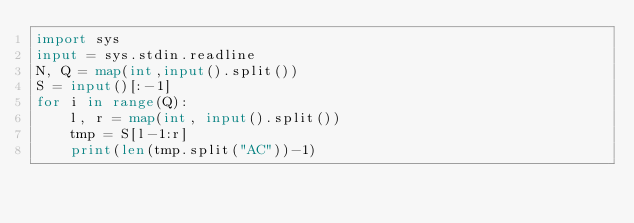Convert code to text. <code><loc_0><loc_0><loc_500><loc_500><_Python_>import sys
input = sys.stdin.readline
N, Q = map(int,input().split())
S = input()[:-1]
for i in range(Q):
    l, r = map(int, input().split())
    tmp = S[l-1:r]
    print(len(tmp.split("AC"))-1)</code> 